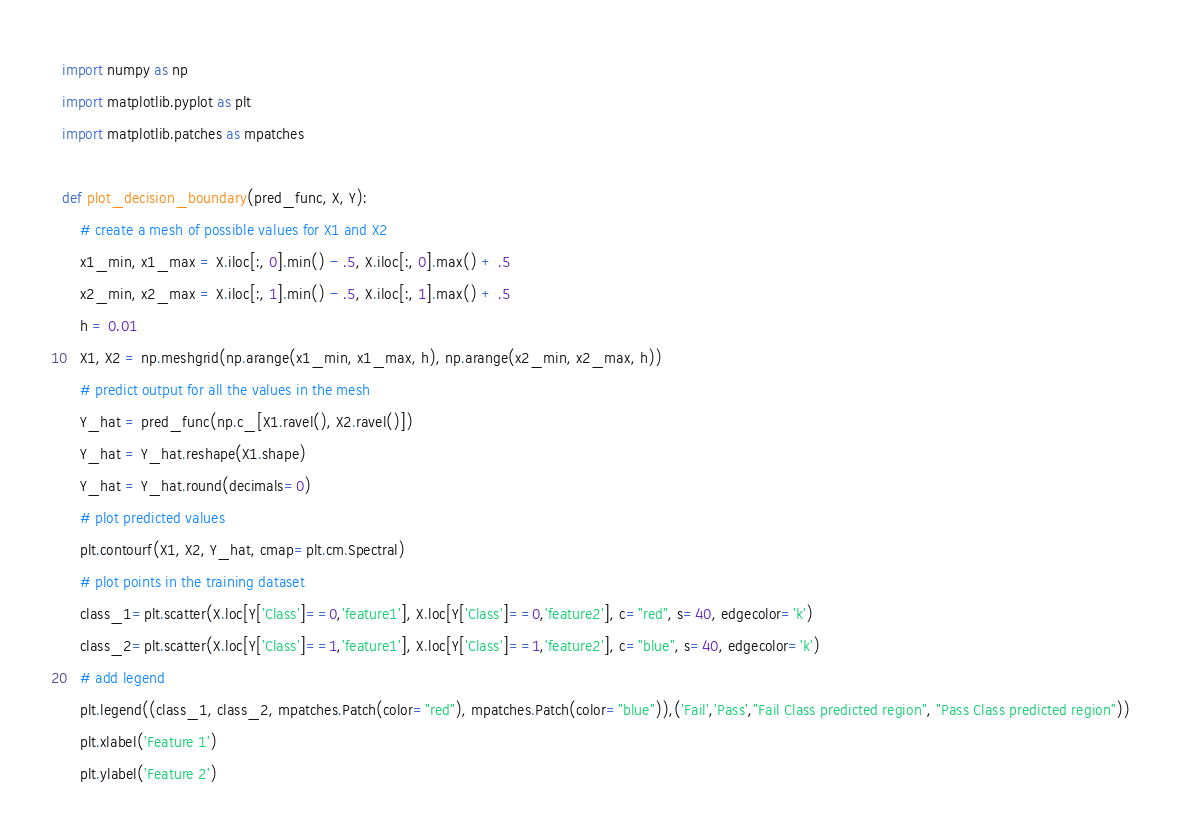Convert code to text. <code><loc_0><loc_0><loc_500><loc_500><_Python_>import numpy as np 
import matplotlib.pyplot as plt 
import matplotlib.patches as mpatches

def plot_decision_boundary(pred_func, X, Y): 
    # create a mesh of possible values for X1 and X2
    x1_min, x1_max = X.iloc[:, 0].min() - .5, X.iloc[:, 0].max() + .5 
    x2_min, x2_max = X.iloc[:, 1].min() - .5, X.iloc[:, 1].max() + .5 
    h = 0.01 
    X1, X2 = np.meshgrid(np.arange(x1_min, x1_max, h), np.arange(x2_min, x2_max, h))
    # predict output for all the values in the mesh
    Y_hat = pred_func(np.c_[X1.ravel(), X2.ravel()]) 
    Y_hat = Y_hat.reshape(X1.shape) 
    Y_hat = Y_hat.round(decimals=0)
    # plot predicted values
    plt.contourf(X1, X2, Y_hat, cmap=plt.cm.Spectral) 
    # plot points in the training dataset
    class_1=plt.scatter(X.loc[Y['Class']==0,'feature1'], X.loc[Y['Class']==0,'feature2'], c="red", s=40, edgecolor='k')
    class_2=plt.scatter(X.loc[Y['Class']==1,'feature1'], X.loc[Y['Class']==1,'feature2'], c="blue", s=40, edgecolor='k')
    # add legend 
    plt.legend((class_1, class_2, mpatches.Patch(color="red"), mpatches.Patch(color="blue")),('Fail','Pass',"Fail Class predicted region", "Pass Class predicted region")) 
    plt.xlabel('Feature 1')
    plt.ylabel('Feature 2')</code> 